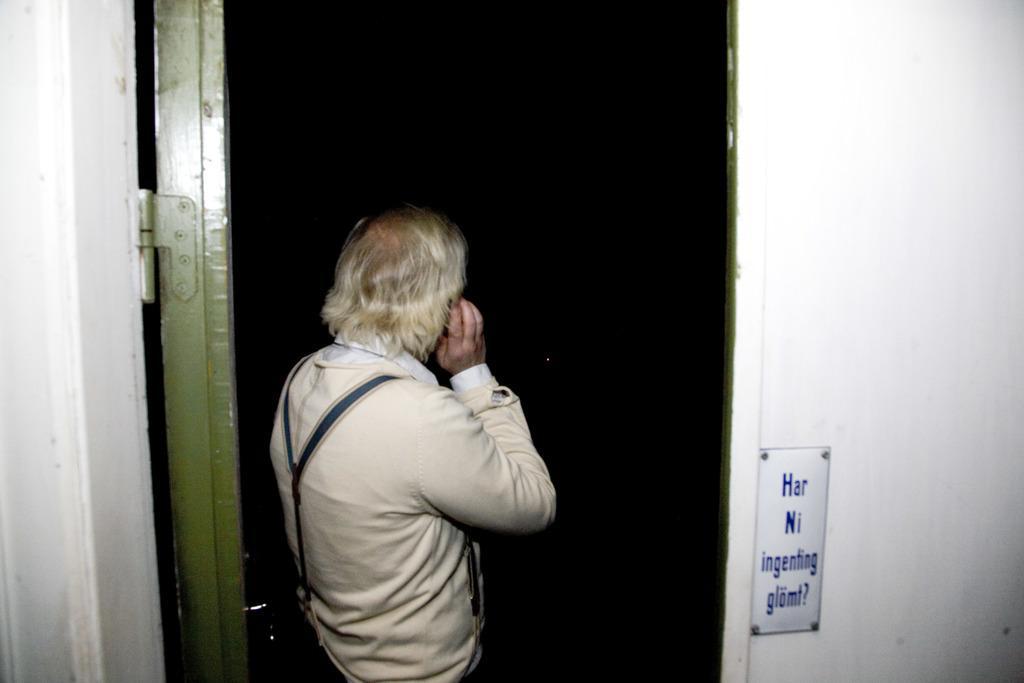Describe this image in one or two sentences. In this image, we can see a person standing, there is a door and we can see the wall. There is a white board with some text on the wall. 